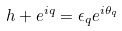<formula> <loc_0><loc_0><loc_500><loc_500>h + e ^ { i q } = \epsilon _ { q } e ^ { i \theta _ { q } }</formula> 